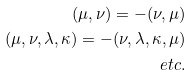Convert formula to latex. <formula><loc_0><loc_0><loc_500><loc_500>( \mu , \nu ) = - ( \nu , \mu ) \\ ( \mu , \nu , \lambda , \kappa ) = - ( \nu , \lambda , \kappa , \mu ) \\ e t c .</formula> 